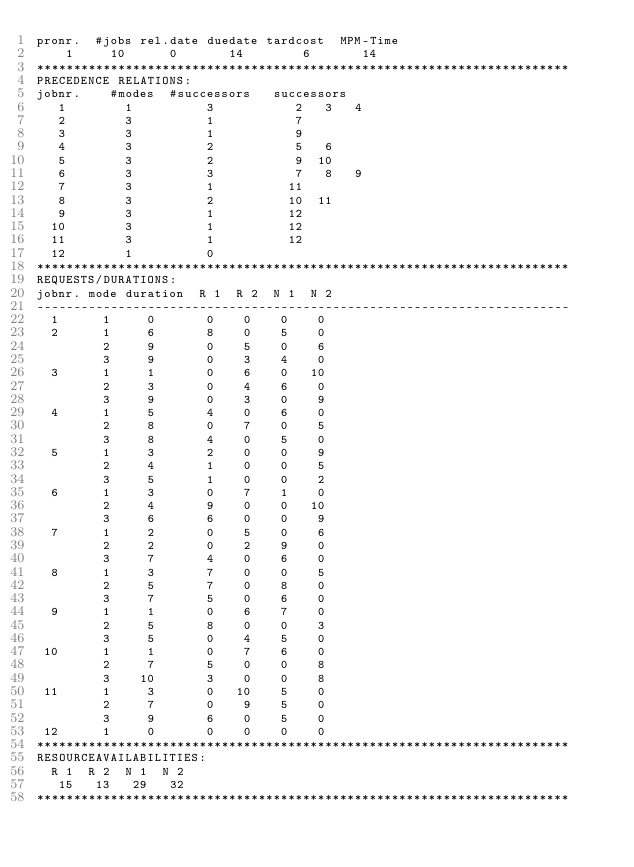<code> <loc_0><loc_0><loc_500><loc_500><_ObjectiveC_>pronr.  #jobs rel.date duedate tardcost  MPM-Time
    1     10      0       14        6       14
************************************************************************
PRECEDENCE RELATIONS:
jobnr.    #modes  #successors   successors
   1        1          3           2   3   4
   2        3          1           7
   3        3          1           9
   4        3          2           5   6
   5        3          2           9  10
   6        3          3           7   8   9
   7        3          1          11
   8        3          2          10  11
   9        3          1          12
  10        3          1          12
  11        3          1          12
  12        1          0        
************************************************************************
REQUESTS/DURATIONS:
jobnr. mode duration  R 1  R 2  N 1  N 2
------------------------------------------------------------------------
  1      1     0       0    0    0    0
  2      1     6       8    0    5    0
         2     9       0    5    0    6
         3     9       0    3    4    0
  3      1     1       0    6    0   10
         2     3       0    4    6    0
         3     9       0    3    0    9
  4      1     5       4    0    6    0
         2     8       0    7    0    5
         3     8       4    0    5    0
  5      1     3       2    0    0    9
         2     4       1    0    0    5
         3     5       1    0    0    2
  6      1     3       0    7    1    0
         2     4       9    0    0   10
         3     6       6    0    0    9
  7      1     2       0    5    0    6
         2     2       0    2    9    0
         3     7       4    0    6    0
  8      1     3       7    0    0    5
         2     5       7    0    8    0
         3     7       5    0    6    0
  9      1     1       0    6    7    0
         2     5       8    0    0    3
         3     5       0    4    5    0
 10      1     1       0    7    6    0
         2     7       5    0    0    8
         3    10       3    0    0    8
 11      1     3       0   10    5    0
         2     7       0    9    5    0
         3     9       6    0    5    0
 12      1     0       0    0    0    0
************************************************************************
RESOURCEAVAILABILITIES:
  R 1  R 2  N 1  N 2
   15   13   29   32
************************************************************************
</code> 